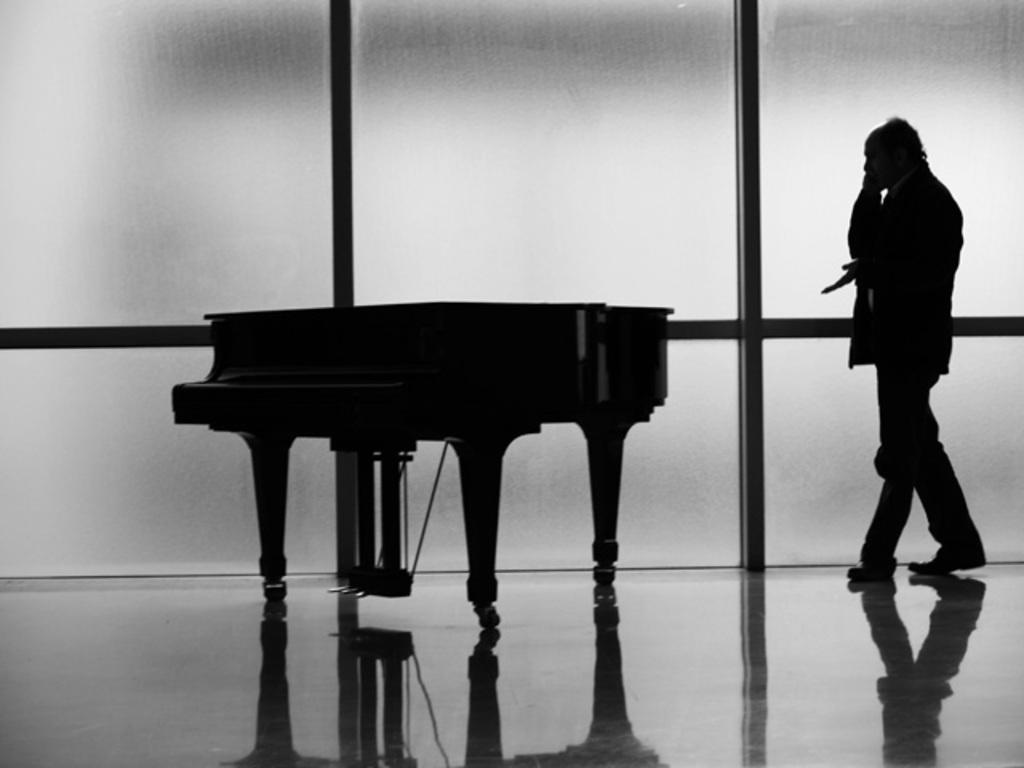What is the color scheme of the image? The image is black and white. What is the man in the image doing? The man is walking in the image. What piece of furniture is present in the room? There is a piano table in the room. What can be seen in the background of the image? There is a wall in the background of the image. Can you see a twig being used as a musical instrument by the man in the image? There is no twig or any indication of it being used as a musical instrument in the image. What type of bird is perched on the piano table in the image? There are no birds, including crows, present in the image. 